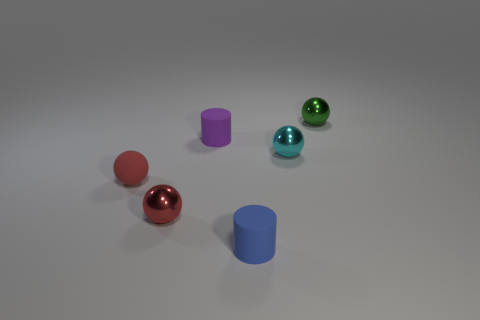What number of small balls are behind the shiny object that is left of the cylinder that is on the right side of the tiny purple cylinder?
Ensure brevity in your answer.  3. What number of red balls are the same size as the blue cylinder?
Offer a terse response. 2. Do the green sphere and the matte cylinder behind the cyan metallic object have the same size?
Give a very brief answer. Yes. How many objects are either tiny shiny cubes or red rubber objects?
Provide a succinct answer. 1. What number of small shiny balls have the same color as the matte ball?
Ensure brevity in your answer.  1. What is the shape of the green metallic thing that is the same size as the red shiny thing?
Keep it short and to the point. Sphere. Are there any cyan things that have the same shape as the red metallic object?
Ensure brevity in your answer.  Yes. What number of other small blue cylinders are made of the same material as the small blue cylinder?
Offer a terse response. 0. Are the red sphere to the left of the red metal sphere and the green sphere made of the same material?
Your answer should be very brief. No. Are there more tiny cyan metallic spheres that are on the right side of the small purple cylinder than red matte balls that are to the right of the red matte sphere?
Provide a succinct answer. Yes. 